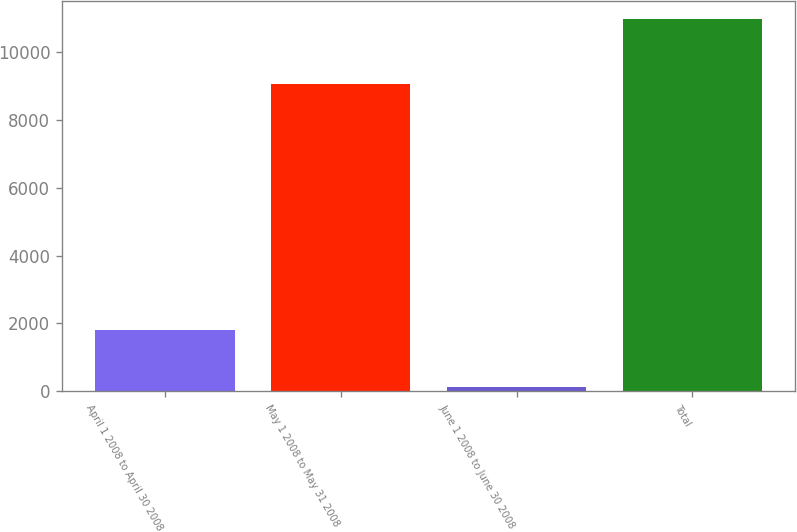Convert chart to OTSL. <chart><loc_0><loc_0><loc_500><loc_500><bar_chart><fcel>April 1 2008 to April 30 2008<fcel>May 1 2008 to May 31 2008<fcel>June 1 2008 to June 30 2008<fcel>Total<nl><fcel>1799<fcel>9061<fcel>118<fcel>10978<nl></chart> 